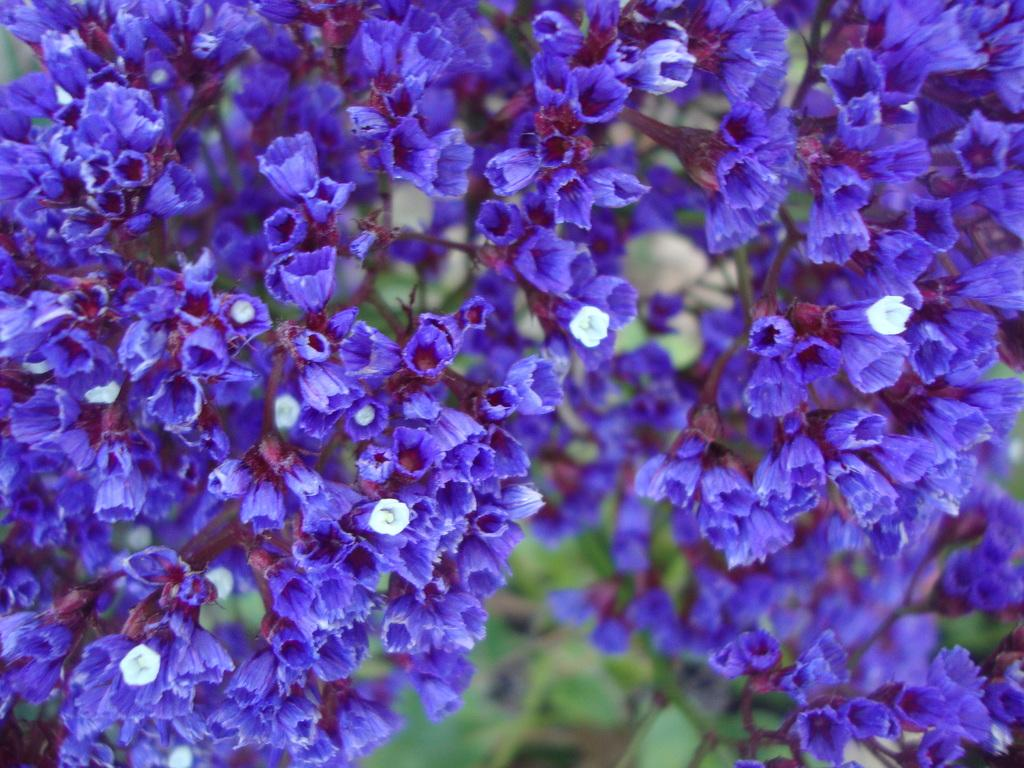What colors are the flowers in the image? The flowers in the image are blue and white. How are the blue and white flowers arranged in the image? The blue and white flowers are interspersed in the image. What type of salt can be seen on the actor's face in the image? There is no actor or salt present in the image; it features blue and white flowers that are interspersed. 